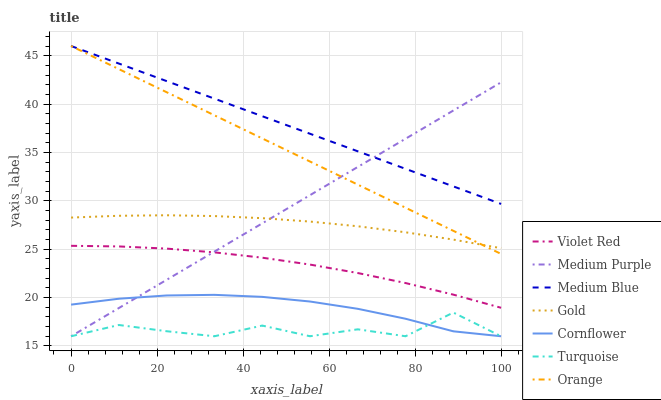Does Turquoise have the minimum area under the curve?
Answer yes or no. Yes. Does Medium Blue have the maximum area under the curve?
Answer yes or no. Yes. Does Violet Red have the minimum area under the curve?
Answer yes or no. No. Does Violet Red have the maximum area under the curve?
Answer yes or no. No. Is Orange the smoothest?
Answer yes or no. Yes. Is Turquoise the roughest?
Answer yes or no. Yes. Is Violet Red the smoothest?
Answer yes or no. No. Is Violet Red the roughest?
Answer yes or no. No. Does Cornflower have the lowest value?
Answer yes or no. Yes. Does Violet Red have the lowest value?
Answer yes or no. No. Does Orange have the highest value?
Answer yes or no. Yes. Does Violet Red have the highest value?
Answer yes or no. No. Is Gold less than Medium Blue?
Answer yes or no. Yes. Is Gold greater than Turquoise?
Answer yes or no. Yes. Does Orange intersect Medium Purple?
Answer yes or no. Yes. Is Orange less than Medium Purple?
Answer yes or no. No. Is Orange greater than Medium Purple?
Answer yes or no. No. Does Gold intersect Medium Blue?
Answer yes or no. No. 